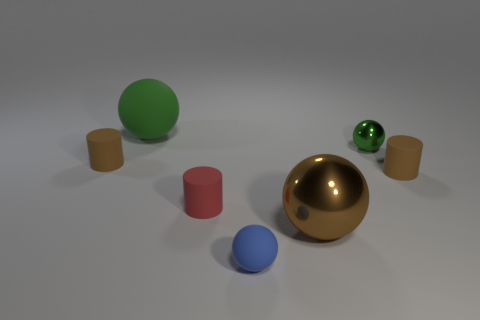Is there any other thing that has the same size as the brown sphere?
Provide a short and direct response. Yes. How many balls are either green matte things or brown matte objects?
Your response must be concise. 1. What number of things are either tiny things on the right side of the red matte cylinder or small green metal things?
Give a very brief answer. 3. What shape is the tiny brown rubber object that is on the right side of the blue rubber sphere that is on the left side of the brown rubber object that is right of the blue thing?
Make the answer very short. Cylinder. What number of brown rubber things have the same shape as the red thing?
Your answer should be compact. 2. There is another thing that is the same color as the big rubber object; what is its material?
Provide a succinct answer. Metal. Is the brown ball made of the same material as the small green sphere?
Provide a succinct answer. Yes. How many tiny rubber things are in front of the tiny green thing on the right side of the matte ball to the left of the blue ball?
Ensure brevity in your answer.  4. Is there a tiny brown cylinder made of the same material as the blue thing?
Offer a very short reply. Yes. There is another ball that is the same color as the tiny shiny sphere; what size is it?
Provide a succinct answer. Large. 